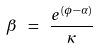<formula> <loc_0><loc_0><loc_500><loc_500>\beta \ = \ \frac { e ^ { ( \phi - \alpha ) } } { \kappa }</formula> 